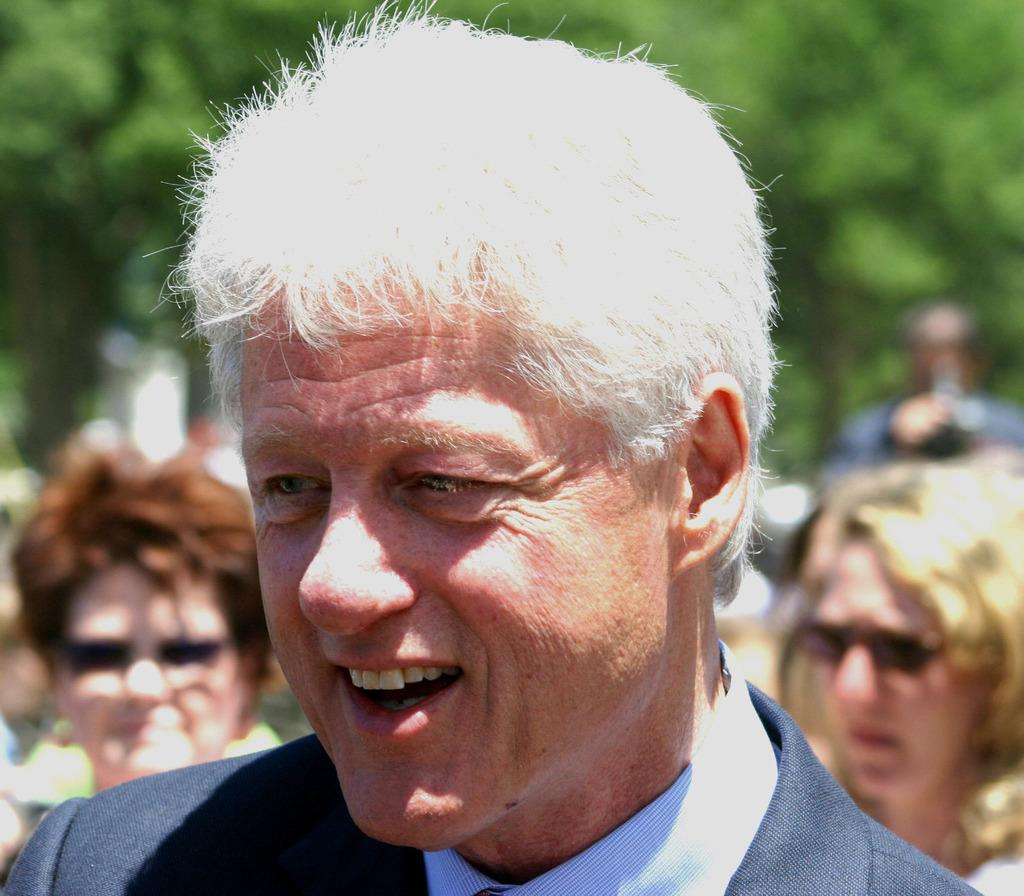How many people are in the image? There is a group of people in the image, but the exact number is not specified. Where are the people located in the image? The people are on the road in the image. What can be seen in the background of the image? There are trees in the background of the image. What time of day was the image likely taken? The image was likely taken during the day, as there is no indication of darkness or artificial lighting. What type of pie is being exchanged between the people in the image? There is no pie or exchange of any kind depicted in the image. 